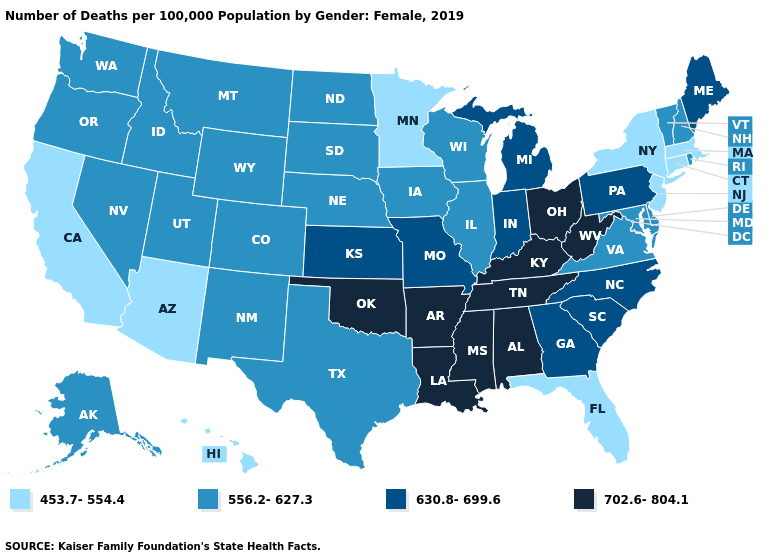What is the value of Texas?
Give a very brief answer. 556.2-627.3. Among the states that border Kentucky , which have the highest value?
Quick response, please. Ohio, Tennessee, West Virginia. Does South Dakota have a lower value than North Dakota?
Give a very brief answer. No. What is the value of Massachusetts?
Give a very brief answer. 453.7-554.4. Name the states that have a value in the range 630.8-699.6?
Quick response, please. Georgia, Indiana, Kansas, Maine, Michigan, Missouri, North Carolina, Pennsylvania, South Carolina. Name the states that have a value in the range 453.7-554.4?
Short answer required. Arizona, California, Connecticut, Florida, Hawaii, Massachusetts, Minnesota, New Jersey, New York. Does Iowa have the same value as Montana?
Give a very brief answer. Yes. Does the map have missing data?
Be succinct. No. What is the highest value in the West ?
Be succinct. 556.2-627.3. Does Maryland have a higher value than Ohio?
Quick response, please. No. What is the value of Virginia?
Short answer required. 556.2-627.3. Name the states that have a value in the range 630.8-699.6?
Quick response, please. Georgia, Indiana, Kansas, Maine, Michigan, Missouri, North Carolina, Pennsylvania, South Carolina. Does Colorado have the highest value in the USA?
Answer briefly. No. Name the states that have a value in the range 702.6-804.1?
Write a very short answer. Alabama, Arkansas, Kentucky, Louisiana, Mississippi, Ohio, Oklahoma, Tennessee, West Virginia. What is the highest value in the West ?
Be succinct. 556.2-627.3. 